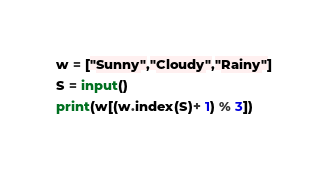<code> <loc_0><loc_0><loc_500><loc_500><_Python_>w = ["Sunny","Cloudy","Rainy"]
S = input()
print(w[(w.index(S)+ 1) % 3])
</code> 